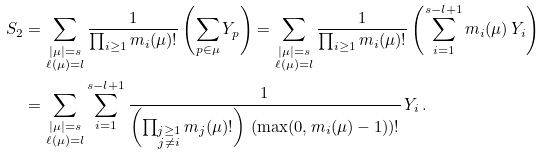<formula> <loc_0><loc_0><loc_500><loc_500>S _ { 2 } & = \sum _ { \substack { | \mu | = s \\ \ell ( \mu ) = l } } \frac { 1 } { \prod _ { i \geq 1 } m _ { i } ( \mu ) ! } \left ( \sum _ { p \in \mu } Y _ { p } \right ) = \sum _ { \substack { | \mu | = s \\ \ell ( \mu ) = l } } \frac { 1 } { \prod _ { i \geq 1 } m _ { i } ( \mu ) ! } \left ( \sum _ { i = 1 } ^ { s - l + 1 } m _ { i } ( \mu ) \, Y _ { i } \right ) \\ & = \sum _ { \substack { | \mu | = s \\ \ell ( \mu ) = l } } \sum _ { i = 1 } ^ { s - l + 1 } \frac { 1 } { \left ( \prod _ { \substack { j \geq 1 \\ j \neq i } } m _ { j } ( \mu ) ! \right ) \, ( \max ( 0 , m _ { i } ( \mu ) - 1 ) ) ! } \, Y _ { i } \, .</formula> 